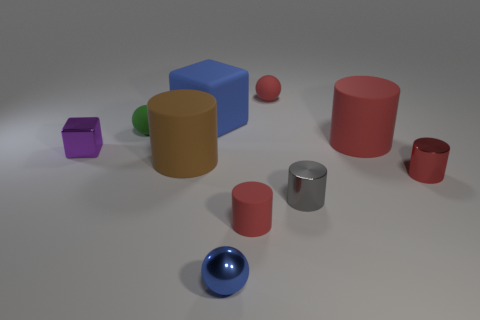There is a large rubber object right of the small blue shiny thing; does it have the same color as the tiny shiny cube?
Offer a very short reply. No. Are there an equal number of large cylinders that are on the right side of the large cube and large cylinders in front of the purple object?
Your response must be concise. Yes. Is there anything else that has the same material as the red sphere?
Offer a terse response. Yes. There is a ball in front of the big red cylinder; what is its color?
Your answer should be compact. Blue. Are there an equal number of spheres that are right of the large rubber block and green rubber objects?
Provide a short and direct response. No. How many other objects are there of the same shape as the large brown object?
Make the answer very short. 4. What number of red rubber balls are on the right side of the large red matte cylinder?
Provide a succinct answer. 0. There is a rubber object that is both behind the green rubber ball and on the left side of the blue shiny sphere; what size is it?
Ensure brevity in your answer.  Large. Are any tiny metal cylinders visible?
Offer a terse response. Yes. How many other things are there of the same size as the purple cube?
Ensure brevity in your answer.  6. 